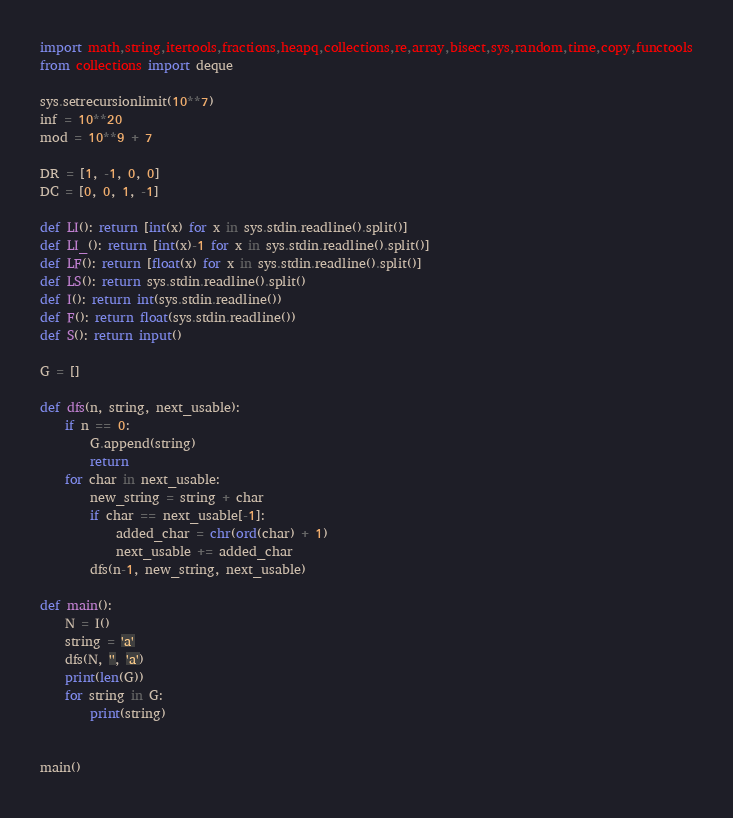<code> <loc_0><loc_0><loc_500><loc_500><_Python_>import math,string,itertools,fractions,heapq,collections,re,array,bisect,sys,random,time,copy,functools
from collections import deque

sys.setrecursionlimit(10**7)
inf = 10**20
mod = 10**9 + 7

DR = [1, -1, 0, 0]
DC = [0, 0, 1, -1]

def LI(): return [int(x) for x in sys.stdin.readline().split()]
def LI_(): return [int(x)-1 for x in sys.stdin.readline().split()]
def LF(): return [float(x) for x in sys.stdin.readline().split()]
def LS(): return sys.stdin.readline().split()
def I(): return int(sys.stdin.readline())
def F(): return float(sys.stdin.readline())
def S(): return input()

G = []

def dfs(n, string, next_usable):
    if n == 0:
        G.append(string)
        return
    for char in next_usable:
        new_string = string + char
        if char == next_usable[-1]:
            added_char = chr(ord(char) + 1)
            next_usable += added_char
        dfs(n-1, new_string, next_usable)

def main():
    N = I()
    string = 'a'
    dfs(N, '', 'a')
    print(len(G))
    for string in G:
        print(string)


main()

</code> 